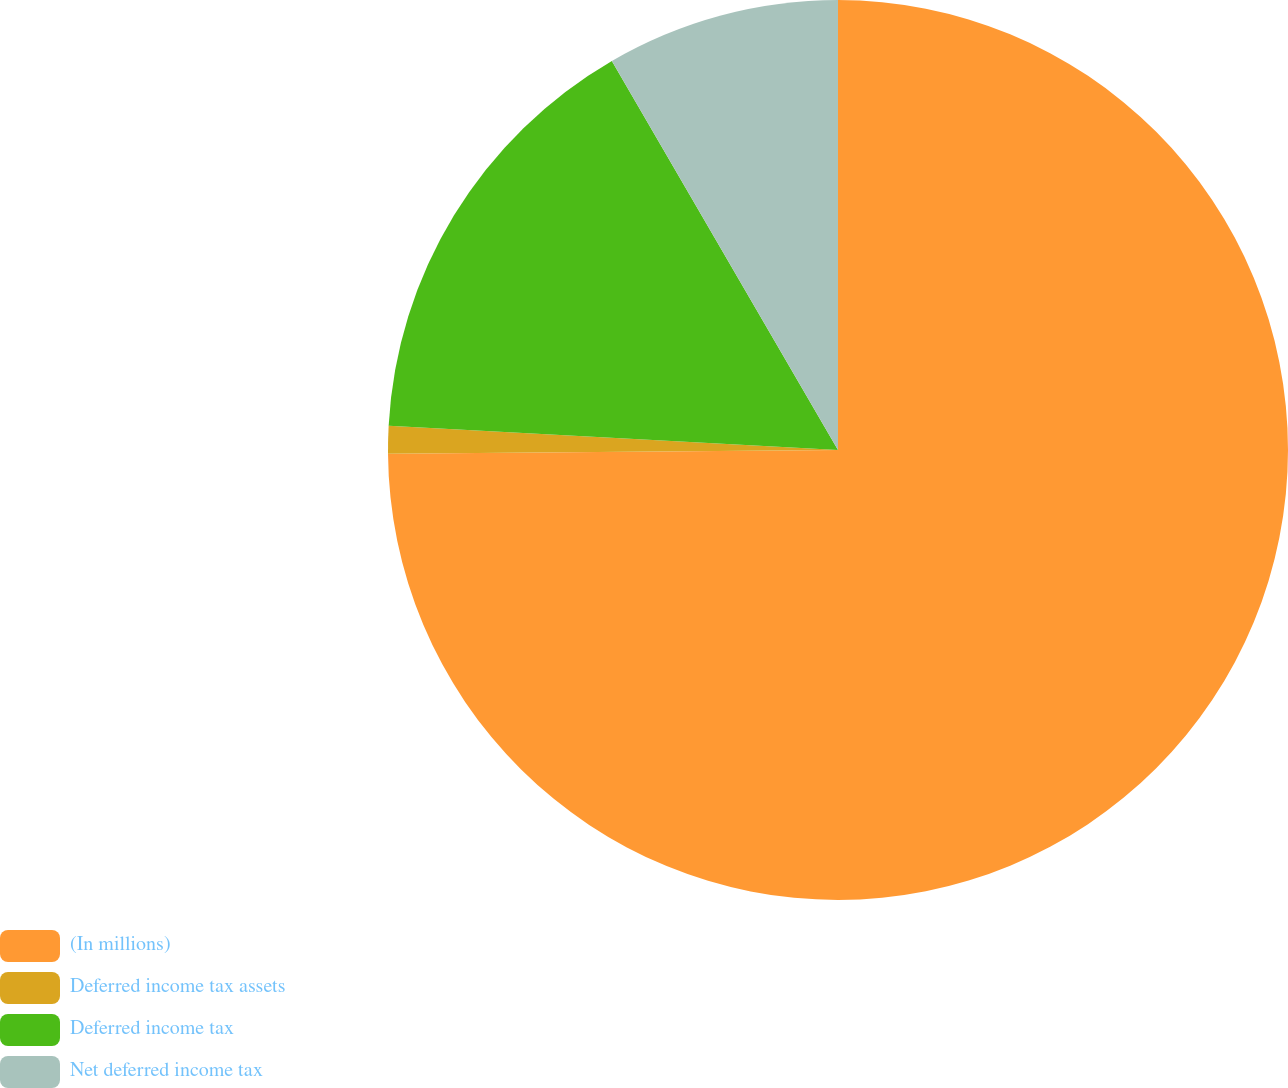<chart> <loc_0><loc_0><loc_500><loc_500><pie_chart><fcel>(In millions)<fcel>Deferred income tax assets<fcel>Deferred income tax<fcel>Net deferred income tax<nl><fcel>74.87%<fcel>0.99%<fcel>15.76%<fcel>8.38%<nl></chart> 